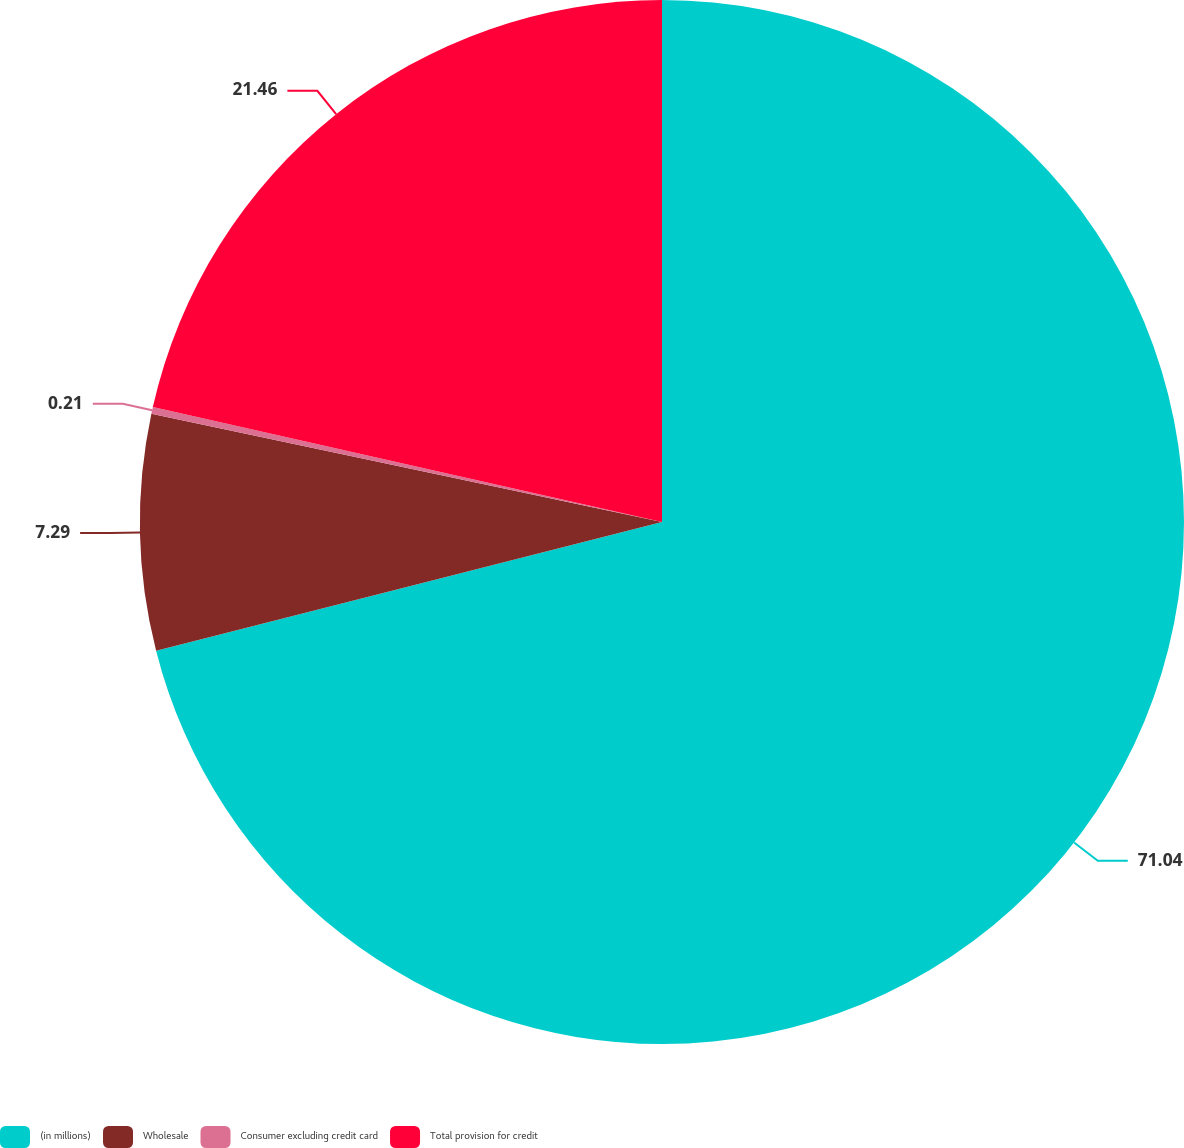<chart> <loc_0><loc_0><loc_500><loc_500><pie_chart><fcel>(in millions)<fcel>Wholesale<fcel>Consumer excluding credit card<fcel>Total provision for credit<nl><fcel>71.03%<fcel>7.29%<fcel>0.21%<fcel>21.46%<nl></chart> 